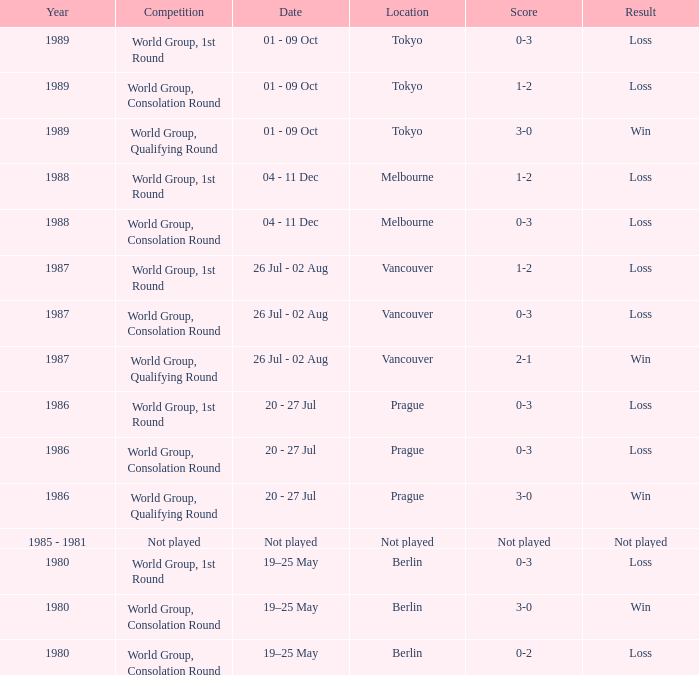What is the rivalry when the conclusion is a loss in berlin with a 0-3 score? World Group, 1st Round. 